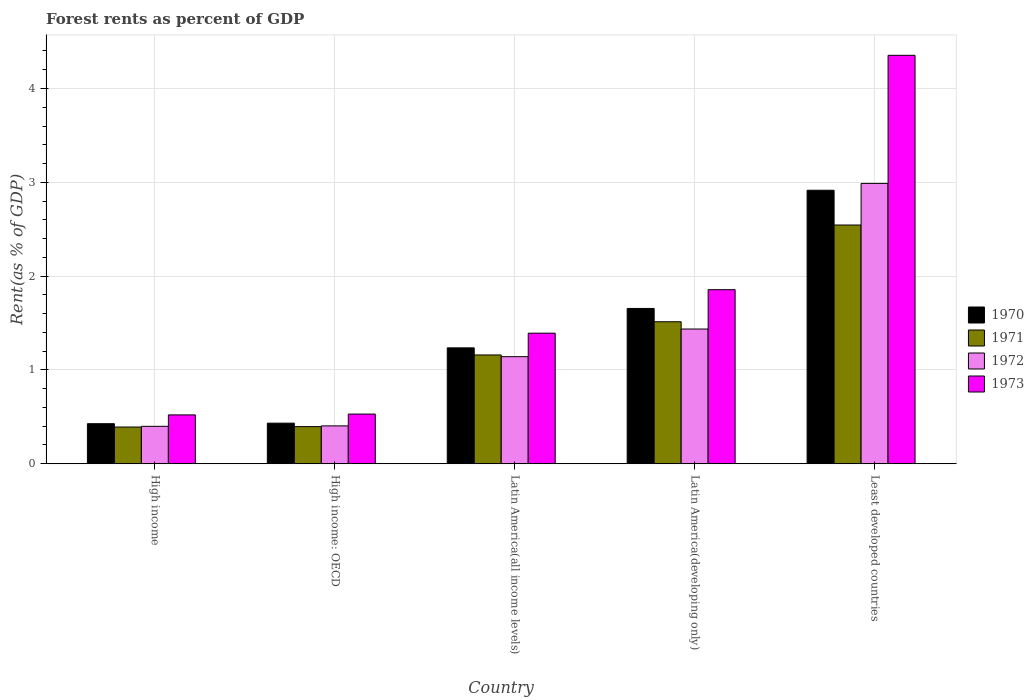How many different coloured bars are there?
Your answer should be compact. 4. Are the number of bars per tick equal to the number of legend labels?
Provide a succinct answer. Yes. Are the number of bars on each tick of the X-axis equal?
Make the answer very short. Yes. How many bars are there on the 1st tick from the left?
Offer a terse response. 4. How many bars are there on the 4th tick from the right?
Provide a short and direct response. 4. What is the label of the 5th group of bars from the left?
Your answer should be very brief. Least developed countries. What is the forest rent in 1972 in Latin America(developing only)?
Offer a terse response. 1.44. Across all countries, what is the maximum forest rent in 1973?
Offer a very short reply. 4.35. Across all countries, what is the minimum forest rent in 1972?
Keep it short and to the point. 0.4. In which country was the forest rent in 1971 maximum?
Your response must be concise. Least developed countries. In which country was the forest rent in 1970 minimum?
Offer a terse response. High income. What is the total forest rent in 1973 in the graph?
Give a very brief answer. 8.65. What is the difference between the forest rent in 1972 in High income: OECD and that in Latin America(developing only)?
Ensure brevity in your answer.  -1.03. What is the difference between the forest rent in 1971 in Least developed countries and the forest rent in 1970 in High income?
Offer a terse response. 2.12. What is the average forest rent in 1973 per country?
Provide a short and direct response. 1.73. What is the difference between the forest rent of/in 1970 and forest rent of/in 1971 in Least developed countries?
Your response must be concise. 0.37. What is the ratio of the forest rent in 1971 in Latin America(all income levels) to that in Least developed countries?
Keep it short and to the point. 0.46. Is the difference between the forest rent in 1970 in High income: OECD and Least developed countries greater than the difference between the forest rent in 1971 in High income: OECD and Least developed countries?
Offer a very short reply. No. What is the difference between the highest and the second highest forest rent in 1972?
Ensure brevity in your answer.  -1.55. What is the difference between the highest and the lowest forest rent in 1970?
Your response must be concise. 2.49. Is the sum of the forest rent in 1973 in High income and Latin America(developing only) greater than the maximum forest rent in 1970 across all countries?
Provide a short and direct response. No. Is it the case that in every country, the sum of the forest rent in 1972 and forest rent in 1971 is greater than the sum of forest rent in 1970 and forest rent in 1973?
Ensure brevity in your answer.  No. What does the 3rd bar from the left in Latin America(all income levels) represents?
Ensure brevity in your answer.  1972. Are all the bars in the graph horizontal?
Your response must be concise. No. Are the values on the major ticks of Y-axis written in scientific E-notation?
Your response must be concise. No. Does the graph contain any zero values?
Provide a short and direct response. No. Does the graph contain grids?
Your answer should be very brief. Yes. Where does the legend appear in the graph?
Your answer should be compact. Center right. What is the title of the graph?
Your answer should be compact. Forest rents as percent of GDP. What is the label or title of the X-axis?
Ensure brevity in your answer.  Country. What is the label or title of the Y-axis?
Offer a terse response. Rent(as % of GDP). What is the Rent(as % of GDP) in 1970 in High income?
Make the answer very short. 0.43. What is the Rent(as % of GDP) in 1971 in High income?
Keep it short and to the point. 0.39. What is the Rent(as % of GDP) of 1972 in High income?
Ensure brevity in your answer.  0.4. What is the Rent(as % of GDP) of 1973 in High income?
Give a very brief answer. 0.52. What is the Rent(as % of GDP) in 1970 in High income: OECD?
Give a very brief answer. 0.43. What is the Rent(as % of GDP) in 1971 in High income: OECD?
Keep it short and to the point. 0.4. What is the Rent(as % of GDP) of 1972 in High income: OECD?
Give a very brief answer. 0.4. What is the Rent(as % of GDP) in 1973 in High income: OECD?
Your answer should be compact. 0.53. What is the Rent(as % of GDP) of 1970 in Latin America(all income levels)?
Offer a terse response. 1.24. What is the Rent(as % of GDP) in 1971 in Latin America(all income levels)?
Your answer should be compact. 1.16. What is the Rent(as % of GDP) of 1972 in Latin America(all income levels)?
Keep it short and to the point. 1.14. What is the Rent(as % of GDP) in 1973 in Latin America(all income levels)?
Your answer should be compact. 1.39. What is the Rent(as % of GDP) in 1970 in Latin America(developing only)?
Provide a succinct answer. 1.66. What is the Rent(as % of GDP) of 1971 in Latin America(developing only)?
Provide a succinct answer. 1.51. What is the Rent(as % of GDP) of 1972 in Latin America(developing only)?
Your response must be concise. 1.44. What is the Rent(as % of GDP) in 1973 in Latin America(developing only)?
Make the answer very short. 1.86. What is the Rent(as % of GDP) in 1970 in Least developed countries?
Your answer should be very brief. 2.92. What is the Rent(as % of GDP) of 1971 in Least developed countries?
Your answer should be very brief. 2.54. What is the Rent(as % of GDP) in 1972 in Least developed countries?
Your answer should be very brief. 2.99. What is the Rent(as % of GDP) in 1973 in Least developed countries?
Your answer should be very brief. 4.35. Across all countries, what is the maximum Rent(as % of GDP) in 1970?
Your answer should be compact. 2.92. Across all countries, what is the maximum Rent(as % of GDP) of 1971?
Make the answer very short. 2.54. Across all countries, what is the maximum Rent(as % of GDP) in 1972?
Offer a terse response. 2.99. Across all countries, what is the maximum Rent(as % of GDP) in 1973?
Your answer should be compact. 4.35. Across all countries, what is the minimum Rent(as % of GDP) of 1970?
Provide a short and direct response. 0.43. Across all countries, what is the minimum Rent(as % of GDP) in 1971?
Offer a terse response. 0.39. Across all countries, what is the minimum Rent(as % of GDP) in 1972?
Give a very brief answer. 0.4. Across all countries, what is the minimum Rent(as % of GDP) of 1973?
Your response must be concise. 0.52. What is the total Rent(as % of GDP) in 1970 in the graph?
Provide a succinct answer. 6.67. What is the total Rent(as % of GDP) of 1971 in the graph?
Provide a succinct answer. 6. What is the total Rent(as % of GDP) in 1972 in the graph?
Make the answer very short. 6.37. What is the total Rent(as % of GDP) in 1973 in the graph?
Keep it short and to the point. 8.65. What is the difference between the Rent(as % of GDP) in 1970 in High income and that in High income: OECD?
Ensure brevity in your answer.  -0.01. What is the difference between the Rent(as % of GDP) of 1971 in High income and that in High income: OECD?
Your answer should be very brief. -0. What is the difference between the Rent(as % of GDP) in 1972 in High income and that in High income: OECD?
Provide a short and direct response. -0. What is the difference between the Rent(as % of GDP) in 1973 in High income and that in High income: OECD?
Keep it short and to the point. -0.01. What is the difference between the Rent(as % of GDP) in 1970 in High income and that in Latin America(all income levels)?
Provide a short and direct response. -0.81. What is the difference between the Rent(as % of GDP) of 1971 in High income and that in Latin America(all income levels)?
Give a very brief answer. -0.77. What is the difference between the Rent(as % of GDP) of 1972 in High income and that in Latin America(all income levels)?
Your answer should be compact. -0.74. What is the difference between the Rent(as % of GDP) in 1973 in High income and that in Latin America(all income levels)?
Give a very brief answer. -0.87. What is the difference between the Rent(as % of GDP) of 1970 in High income and that in Latin America(developing only)?
Provide a short and direct response. -1.23. What is the difference between the Rent(as % of GDP) in 1971 in High income and that in Latin America(developing only)?
Ensure brevity in your answer.  -1.12. What is the difference between the Rent(as % of GDP) in 1972 in High income and that in Latin America(developing only)?
Provide a succinct answer. -1.04. What is the difference between the Rent(as % of GDP) of 1973 in High income and that in Latin America(developing only)?
Your answer should be compact. -1.33. What is the difference between the Rent(as % of GDP) in 1970 in High income and that in Least developed countries?
Provide a short and direct response. -2.49. What is the difference between the Rent(as % of GDP) of 1971 in High income and that in Least developed countries?
Make the answer very short. -2.15. What is the difference between the Rent(as % of GDP) in 1972 in High income and that in Least developed countries?
Your answer should be compact. -2.59. What is the difference between the Rent(as % of GDP) of 1973 in High income and that in Least developed countries?
Provide a succinct answer. -3.83. What is the difference between the Rent(as % of GDP) in 1970 in High income: OECD and that in Latin America(all income levels)?
Provide a short and direct response. -0.8. What is the difference between the Rent(as % of GDP) of 1971 in High income: OECD and that in Latin America(all income levels)?
Your answer should be very brief. -0.76. What is the difference between the Rent(as % of GDP) in 1972 in High income: OECD and that in Latin America(all income levels)?
Provide a short and direct response. -0.74. What is the difference between the Rent(as % of GDP) of 1973 in High income: OECD and that in Latin America(all income levels)?
Offer a very short reply. -0.86. What is the difference between the Rent(as % of GDP) of 1970 in High income: OECD and that in Latin America(developing only)?
Give a very brief answer. -1.22. What is the difference between the Rent(as % of GDP) of 1971 in High income: OECD and that in Latin America(developing only)?
Keep it short and to the point. -1.12. What is the difference between the Rent(as % of GDP) of 1972 in High income: OECD and that in Latin America(developing only)?
Your response must be concise. -1.03. What is the difference between the Rent(as % of GDP) of 1973 in High income: OECD and that in Latin America(developing only)?
Offer a very short reply. -1.33. What is the difference between the Rent(as % of GDP) in 1970 in High income: OECD and that in Least developed countries?
Provide a succinct answer. -2.48. What is the difference between the Rent(as % of GDP) in 1971 in High income: OECD and that in Least developed countries?
Give a very brief answer. -2.15. What is the difference between the Rent(as % of GDP) in 1972 in High income: OECD and that in Least developed countries?
Your response must be concise. -2.58. What is the difference between the Rent(as % of GDP) in 1973 in High income: OECD and that in Least developed countries?
Your answer should be compact. -3.82. What is the difference between the Rent(as % of GDP) in 1970 in Latin America(all income levels) and that in Latin America(developing only)?
Provide a short and direct response. -0.42. What is the difference between the Rent(as % of GDP) in 1971 in Latin America(all income levels) and that in Latin America(developing only)?
Give a very brief answer. -0.35. What is the difference between the Rent(as % of GDP) of 1972 in Latin America(all income levels) and that in Latin America(developing only)?
Your response must be concise. -0.29. What is the difference between the Rent(as % of GDP) of 1973 in Latin America(all income levels) and that in Latin America(developing only)?
Your answer should be compact. -0.46. What is the difference between the Rent(as % of GDP) in 1970 in Latin America(all income levels) and that in Least developed countries?
Offer a terse response. -1.68. What is the difference between the Rent(as % of GDP) in 1971 in Latin America(all income levels) and that in Least developed countries?
Ensure brevity in your answer.  -1.39. What is the difference between the Rent(as % of GDP) of 1972 in Latin America(all income levels) and that in Least developed countries?
Provide a succinct answer. -1.85. What is the difference between the Rent(as % of GDP) of 1973 in Latin America(all income levels) and that in Least developed countries?
Your answer should be very brief. -2.96. What is the difference between the Rent(as % of GDP) in 1970 in Latin America(developing only) and that in Least developed countries?
Offer a very short reply. -1.26. What is the difference between the Rent(as % of GDP) of 1971 in Latin America(developing only) and that in Least developed countries?
Offer a terse response. -1.03. What is the difference between the Rent(as % of GDP) in 1972 in Latin America(developing only) and that in Least developed countries?
Provide a short and direct response. -1.55. What is the difference between the Rent(as % of GDP) of 1973 in Latin America(developing only) and that in Least developed countries?
Keep it short and to the point. -2.5. What is the difference between the Rent(as % of GDP) in 1970 in High income and the Rent(as % of GDP) in 1971 in High income: OECD?
Your answer should be very brief. 0.03. What is the difference between the Rent(as % of GDP) of 1970 in High income and the Rent(as % of GDP) of 1972 in High income: OECD?
Offer a terse response. 0.02. What is the difference between the Rent(as % of GDP) of 1970 in High income and the Rent(as % of GDP) of 1973 in High income: OECD?
Provide a short and direct response. -0.1. What is the difference between the Rent(as % of GDP) of 1971 in High income and the Rent(as % of GDP) of 1972 in High income: OECD?
Your answer should be compact. -0.01. What is the difference between the Rent(as % of GDP) in 1971 in High income and the Rent(as % of GDP) in 1973 in High income: OECD?
Keep it short and to the point. -0.14. What is the difference between the Rent(as % of GDP) of 1972 in High income and the Rent(as % of GDP) of 1973 in High income: OECD?
Offer a very short reply. -0.13. What is the difference between the Rent(as % of GDP) in 1970 in High income and the Rent(as % of GDP) in 1971 in Latin America(all income levels)?
Ensure brevity in your answer.  -0.73. What is the difference between the Rent(as % of GDP) in 1970 in High income and the Rent(as % of GDP) in 1972 in Latin America(all income levels)?
Ensure brevity in your answer.  -0.71. What is the difference between the Rent(as % of GDP) of 1970 in High income and the Rent(as % of GDP) of 1973 in Latin America(all income levels)?
Offer a terse response. -0.96. What is the difference between the Rent(as % of GDP) of 1971 in High income and the Rent(as % of GDP) of 1972 in Latin America(all income levels)?
Your answer should be very brief. -0.75. What is the difference between the Rent(as % of GDP) in 1971 in High income and the Rent(as % of GDP) in 1973 in Latin America(all income levels)?
Provide a succinct answer. -1. What is the difference between the Rent(as % of GDP) of 1972 in High income and the Rent(as % of GDP) of 1973 in Latin America(all income levels)?
Offer a terse response. -0.99. What is the difference between the Rent(as % of GDP) in 1970 in High income and the Rent(as % of GDP) in 1971 in Latin America(developing only)?
Offer a very short reply. -1.09. What is the difference between the Rent(as % of GDP) of 1970 in High income and the Rent(as % of GDP) of 1972 in Latin America(developing only)?
Make the answer very short. -1.01. What is the difference between the Rent(as % of GDP) of 1970 in High income and the Rent(as % of GDP) of 1973 in Latin America(developing only)?
Keep it short and to the point. -1.43. What is the difference between the Rent(as % of GDP) in 1971 in High income and the Rent(as % of GDP) in 1972 in Latin America(developing only)?
Offer a terse response. -1.04. What is the difference between the Rent(as % of GDP) in 1971 in High income and the Rent(as % of GDP) in 1973 in Latin America(developing only)?
Your answer should be compact. -1.46. What is the difference between the Rent(as % of GDP) of 1972 in High income and the Rent(as % of GDP) of 1973 in Latin America(developing only)?
Ensure brevity in your answer.  -1.46. What is the difference between the Rent(as % of GDP) in 1970 in High income and the Rent(as % of GDP) in 1971 in Least developed countries?
Offer a very short reply. -2.12. What is the difference between the Rent(as % of GDP) of 1970 in High income and the Rent(as % of GDP) of 1972 in Least developed countries?
Offer a terse response. -2.56. What is the difference between the Rent(as % of GDP) in 1970 in High income and the Rent(as % of GDP) in 1973 in Least developed countries?
Your answer should be very brief. -3.93. What is the difference between the Rent(as % of GDP) in 1971 in High income and the Rent(as % of GDP) in 1972 in Least developed countries?
Offer a terse response. -2.6. What is the difference between the Rent(as % of GDP) in 1971 in High income and the Rent(as % of GDP) in 1973 in Least developed countries?
Your answer should be compact. -3.96. What is the difference between the Rent(as % of GDP) in 1972 in High income and the Rent(as % of GDP) in 1973 in Least developed countries?
Keep it short and to the point. -3.95. What is the difference between the Rent(as % of GDP) in 1970 in High income: OECD and the Rent(as % of GDP) in 1971 in Latin America(all income levels)?
Provide a short and direct response. -0.73. What is the difference between the Rent(as % of GDP) in 1970 in High income: OECD and the Rent(as % of GDP) in 1972 in Latin America(all income levels)?
Provide a short and direct response. -0.71. What is the difference between the Rent(as % of GDP) of 1970 in High income: OECD and the Rent(as % of GDP) of 1973 in Latin America(all income levels)?
Your answer should be very brief. -0.96. What is the difference between the Rent(as % of GDP) in 1971 in High income: OECD and the Rent(as % of GDP) in 1972 in Latin America(all income levels)?
Provide a succinct answer. -0.75. What is the difference between the Rent(as % of GDP) in 1971 in High income: OECD and the Rent(as % of GDP) in 1973 in Latin America(all income levels)?
Provide a short and direct response. -1. What is the difference between the Rent(as % of GDP) of 1972 in High income: OECD and the Rent(as % of GDP) of 1973 in Latin America(all income levels)?
Keep it short and to the point. -0.99. What is the difference between the Rent(as % of GDP) of 1970 in High income: OECD and the Rent(as % of GDP) of 1971 in Latin America(developing only)?
Your answer should be compact. -1.08. What is the difference between the Rent(as % of GDP) of 1970 in High income: OECD and the Rent(as % of GDP) of 1972 in Latin America(developing only)?
Your response must be concise. -1. What is the difference between the Rent(as % of GDP) in 1970 in High income: OECD and the Rent(as % of GDP) in 1973 in Latin America(developing only)?
Your answer should be compact. -1.42. What is the difference between the Rent(as % of GDP) in 1971 in High income: OECD and the Rent(as % of GDP) in 1972 in Latin America(developing only)?
Provide a short and direct response. -1.04. What is the difference between the Rent(as % of GDP) in 1971 in High income: OECD and the Rent(as % of GDP) in 1973 in Latin America(developing only)?
Your answer should be very brief. -1.46. What is the difference between the Rent(as % of GDP) of 1972 in High income: OECD and the Rent(as % of GDP) of 1973 in Latin America(developing only)?
Give a very brief answer. -1.45. What is the difference between the Rent(as % of GDP) in 1970 in High income: OECD and the Rent(as % of GDP) in 1971 in Least developed countries?
Keep it short and to the point. -2.11. What is the difference between the Rent(as % of GDP) of 1970 in High income: OECD and the Rent(as % of GDP) of 1972 in Least developed countries?
Give a very brief answer. -2.56. What is the difference between the Rent(as % of GDP) in 1970 in High income: OECD and the Rent(as % of GDP) in 1973 in Least developed countries?
Your response must be concise. -3.92. What is the difference between the Rent(as % of GDP) in 1971 in High income: OECD and the Rent(as % of GDP) in 1972 in Least developed countries?
Offer a very short reply. -2.59. What is the difference between the Rent(as % of GDP) of 1971 in High income: OECD and the Rent(as % of GDP) of 1973 in Least developed countries?
Provide a succinct answer. -3.96. What is the difference between the Rent(as % of GDP) of 1972 in High income: OECD and the Rent(as % of GDP) of 1973 in Least developed countries?
Keep it short and to the point. -3.95. What is the difference between the Rent(as % of GDP) of 1970 in Latin America(all income levels) and the Rent(as % of GDP) of 1971 in Latin America(developing only)?
Keep it short and to the point. -0.28. What is the difference between the Rent(as % of GDP) of 1970 in Latin America(all income levels) and the Rent(as % of GDP) of 1972 in Latin America(developing only)?
Your answer should be very brief. -0.2. What is the difference between the Rent(as % of GDP) in 1970 in Latin America(all income levels) and the Rent(as % of GDP) in 1973 in Latin America(developing only)?
Your answer should be compact. -0.62. What is the difference between the Rent(as % of GDP) in 1971 in Latin America(all income levels) and the Rent(as % of GDP) in 1972 in Latin America(developing only)?
Make the answer very short. -0.28. What is the difference between the Rent(as % of GDP) of 1971 in Latin America(all income levels) and the Rent(as % of GDP) of 1973 in Latin America(developing only)?
Your answer should be very brief. -0.7. What is the difference between the Rent(as % of GDP) in 1972 in Latin America(all income levels) and the Rent(as % of GDP) in 1973 in Latin America(developing only)?
Your answer should be compact. -0.71. What is the difference between the Rent(as % of GDP) in 1970 in Latin America(all income levels) and the Rent(as % of GDP) in 1971 in Least developed countries?
Provide a short and direct response. -1.31. What is the difference between the Rent(as % of GDP) in 1970 in Latin America(all income levels) and the Rent(as % of GDP) in 1972 in Least developed countries?
Your answer should be very brief. -1.75. What is the difference between the Rent(as % of GDP) in 1970 in Latin America(all income levels) and the Rent(as % of GDP) in 1973 in Least developed countries?
Your answer should be compact. -3.12. What is the difference between the Rent(as % of GDP) in 1971 in Latin America(all income levels) and the Rent(as % of GDP) in 1972 in Least developed countries?
Ensure brevity in your answer.  -1.83. What is the difference between the Rent(as % of GDP) of 1971 in Latin America(all income levels) and the Rent(as % of GDP) of 1973 in Least developed countries?
Keep it short and to the point. -3.19. What is the difference between the Rent(as % of GDP) of 1972 in Latin America(all income levels) and the Rent(as % of GDP) of 1973 in Least developed countries?
Provide a succinct answer. -3.21. What is the difference between the Rent(as % of GDP) in 1970 in Latin America(developing only) and the Rent(as % of GDP) in 1971 in Least developed countries?
Offer a terse response. -0.89. What is the difference between the Rent(as % of GDP) of 1970 in Latin America(developing only) and the Rent(as % of GDP) of 1972 in Least developed countries?
Provide a short and direct response. -1.33. What is the difference between the Rent(as % of GDP) in 1970 in Latin America(developing only) and the Rent(as % of GDP) in 1973 in Least developed countries?
Give a very brief answer. -2.7. What is the difference between the Rent(as % of GDP) of 1971 in Latin America(developing only) and the Rent(as % of GDP) of 1972 in Least developed countries?
Offer a very short reply. -1.47. What is the difference between the Rent(as % of GDP) of 1971 in Latin America(developing only) and the Rent(as % of GDP) of 1973 in Least developed countries?
Provide a short and direct response. -2.84. What is the difference between the Rent(as % of GDP) in 1972 in Latin America(developing only) and the Rent(as % of GDP) in 1973 in Least developed countries?
Keep it short and to the point. -2.92. What is the average Rent(as % of GDP) in 1970 per country?
Your answer should be compact. 1.33. What is the average Rent(as % of GDP) of 1971 per country?
Keep it short and to the point. 1.2. What is the average Rent(as % of GDP) of 1972 per country?
Ensure brevity in your answer.  1.27. What is the average Rent(as % of GDP) in 1973 per country?
Offer a very short reply. 1.73. What is the difference between the Rent(as % of GDP) in 1970 and Rent(as % of GDP) in 1971 in High income?
Ensure brevity in your answer.  0.04. What is the difference between the Rent(as % of GDP) in 1970 and Rent(as % of GDP) in 1972 in High income?
Your answer should be compact. 0.03. What is the difference between the Rent(as % of GDP) in 1970 and Rent(as % of GDP) in 1973 in High income?
Offer a terse response. -0.09. What is the difference between the Rent(as % of GDP) of 1971 and Rent(as % of GDP) of 1972 in High income?
Offer a terse response. -0.01. What is the difference between the Rent(as % of GDP) in 1971 and Rent(as % of GDP) in 1973 in High income?
Provide a succinct answer. -0.13. What is the difference between the Rent(as % of GDP) in 1972 and Rent(as % of GDP) in 1973 in High income?
Offer a very short reply. -0.12. What is the difference between the Rent(as % of GDP) in 1970 and Rent(as % of GDP) in 1971 in High income: OECD?
Offer a very short reply. 0.04. What is the difference between the Rent(as % of GDP) of 1970 and Rent(as % of GDP) of 1972 in High income: OECD?
Give a very brief answer. 0.03. What is the difference between the Rent(as % of GDP) in 1970 and Rent(as % of GDP) in 1973 in High income: OECD?
Keep it short and to the point. -0.1. What is the difference between the Rent(as % of GDP) of 1971 and Rent(as % of GDP) of 1972 in High income: OECD?
Keep it short and to the point. -0.01. What is the difference between the Rent(as % of GDP) in 1971 and Rent(as % of GDP) in 1973 in High income: OECD?
Your answer should be very brief. -0.13. What is the difference between the Rent(as % of GDP) of 1972 and Rent(as % of GDP) of 1973 in High income: OECD?
Make the answer very short. -0.13. What is the difference between the Rent(as % of GDP) of 1970 and Rent(as % of GDP) of 1971 in Latin America(all income levels)?
Provide a succinct answer. 0.08. What is the difference between the Rent(as % of GDP) in 1970 and Rent(as % of GDP) in 1972 in Latin America(all income levels)?
Your response must be concise. 0.09. What is the difference between the Rent(as % of GDP) in 1970 and Rent(as % of GDP) in 1973 in Latin America(all income levels)?
Provide a succinct answer. -0.16. What is the difference between the Rent(as % of GDP) of 1971 and Rent(as % of GDP) of 1972 in Latin America(all income levels)?
Offer a terse response. 0.02. What is the difference between the Rent(as % of GDP) of 1971 and Rent(as % of GDP) of 1973 in Latin America(all income levels)?
Your answer should be compact. -0.23. What is the difference between the Rent(as % of GDP) of 1972 and Rent(as % of GDP) of 1973 in Latin America(all income levels)?
Provide a succinct answer. -0.25. What is the difference between the Rent(as % of GDP) in 1970 and Rent(as % of GDP) in 1971 in Latin America(developing only)?
Your answer should be compact. 0.14. What is the difference between the Rent(as % of GDP) of 1970 and Rent(as % of GDP) of 1972 in Latin America(developing only)?
Give a very brief answer. 0.22. What is the difference between the Rent(as % of GDP) of 1970 and Rent(as % of GDP) of 1973 in Latin America(developing only)?
Ensure brevity in your answer.  -0.2. What is the difference between the Rent(as % of GDP) of 1971 and Rent(as % of GDP) of 1972 in Latin America(developing only)?
Offer a terse response. 0.08. What is the difference between the Rent(as % of GDP) in 1971 and Rent(as % of GDP) in 1973 in Latin America(developing only)?
Make the answer very short. -0.34. What is the difference between the Rent(as % of GDP) of 1972 and Rent(as % of GDP) of 1973 in Latin America(developing only)?
Keep it short and to the point. -0.42. What is the difference between the Rent(as % of GDP) in 1970 and Rent(as % of GDP) in 1971 in Least developed countries?
Offer a terse response. 0.37. What is the difference between the Rent(as % of GDP) of 1970 and Rent(as % of GDP) of 1972 in Least developed countries?
Offer a terse response. -0.07. What is the difference between the Rent(as % of GDP) of 1970 and Rent(as % of GDP) of 1973 in Least developed countries?
Make the answer very short. -1.44. What is the difference between the Rent(as % of GDP) in 1971 and Rent(as % of GDP) in 1972 in Least developed countries?
Your answer should be compact. -0.44. What is the difference between the Rent(as % of GDP) of 1971 and Rent(as % of GDP) of 1973 in Least developed countries?
Offer a terse response. -1.81. What is the difference between the Rent(as % of GDP) of 1972 and Rent(as % of GDP) of 1973 in Least developed countries?
Provide a short and direct response. -1.37. What is the ratio of the Rent(as % of GDP) of 1970 in High income to that in High income: OECD?
Keep it short and to the point. 0.99. What is the ratio of the Rent(as % of GDP) in 1973 in High income to that in High income: OECD?
Offer a very short reply. 0.98. What is the ratio of the Rent(as % of GDP) of 1970 in High income to that in Latin America(all income levels)?
Your response must be concise. 0.35. What is the ratio of the Rent(as % of GDP) in 1971 in High income to that in Latin America(all income levels)?
Ensure brevity in your answer.  0.34. What is the ratio of the Rent(as % of GDP) in 1972 in High income to that in Latin America(all income levels)?
Your response must be concise. 0.35. What is the ratio of the Rent(as % of GDP) of 1973 in High income to that in Latin America(all income levels)?
Provide a short and direct response. 0.37. What is the ratio of the Rent(as % of GDP) in 1970 in High income to that in Latin America(developing only)?
Keep it short and to the point. 0.26. What is the ratio of the Rent(as % of GDP) of 1971 in High income to that in Latin America(developing only)?
Make the answer very short. 0.26. What is the ratio of the Rent(as % of GDP) in 1972 in High income to that in Latin America(developing only)?
Ensure brevity in your answer.  0.28. What is the ratio of the Rent(as % of GDP) of 1973 in High income to that in Latin America(developing only)?
Make the answer very short. 0.28. What is the ratio of the Rent(as % of GDP) of 1970 in High income to that in Least developed countries?
Your answer should be compact. 0.15. What is the ratio of the Rent(as % of GDP) in 1971 in High income to that in Least developed countries?
Your answer should be very brief. 0.15. What is the ratio of the Rent(as % of GDP) in 1972 in High income to that in Least developed countries?
Offer a terse response. 0.13. What is the ratio of the Rent(as % of GDP) of 1973 in High income to that in Least developed countries?
Provide a short and direct response. 0.12. What is the ratio of the Rent(as % of GDP) of 1970 in High income: OECD to that in Latin America(all income levels)?
Offer a terse response. 0.35. What is the ratio of the Rent(as % of GDP) in 1971 in High income: OECD to that in Latin America(all income levels)?
Ensure brevity in your answer.  0.34. What is the ratio of the Rent(as % of GDP) of 1972 in High income: OECD to that in Latin America(all income levels)?
Your answer should be compact. 0.35. What is the ratio of the Rent(as % of GDP) in 1973 in High income: OECD to that in Latin America(all income levels)?
Offer a very short reply. 0.38. What is the ratio of the Rent(as % of GDP) in 1970 in High income: OECD to that in Latin America(developing only)?
Your answer should be very brief. 0.26. What is the ratio of the Rent(as % of GDP) in 1971 in High income: OECD to that in Latin America(developing only)?
Keep it short and to the point. 0.26. What is the ratio of the Rent(as % of GDP) in 1972 in High income: OECD to that in Latin America(developing only)?
Ensure brevity in your answer.  0.28. What is the ratio of the Rent(as % of GDP) in 1973 in High income: OECD to that in Latin America(developing only)?
Your answer should be compact. 0.29. What is the ratio of the Rent(as % of GDP) of 1970 in High income: OECD to that in Least developed countries?
Your answer should be very brief. 0.15. What is the ratio of the Rent(as % of GDP) of 1971 in High income: OECD to that in Least developed countries?
Your answer should be compact. 0.16. What is the ratio of the Rent(as % of GDP) of 1972 in High income: OECD to that in Least developed countries?
Your response must be concise. 0.14. What is the ratio of the Rent(as % of GDP) in 1973 in High income: OECD to that in Least developed countries?
Provide a short and direct response. 0.12. What is the ratio of the Rent(as % of GDP) in 1970 in Latin America(all income levels) to that in Latin America(developing only)?
Your response must be concise. 0.75. What is the ratio of the Rent(as % of GDP) in 1971 in Latin America(all income levels) to that in Latin America(developing only)?
Your answer should be very brief. 0.77. What is the ratio of the Rent(as % of GDP) in 1972 in Latin America(all income levels) to that in Latin America(developing only)?
Your answer should be compact. 0.79. What is the ratio of the Rent(as % of GDP) in 1973 in Latin America(all income levels) to that in Latin America(developing only)?
Offer a very short reply. 0.75. What is the ratio of the Rent(as % of GDP) of 1970 in Latin America(all income levels) to that in Least developed countries?
Make the answer very short. 0.42. What is the ratio of the Rent(as % of GDP) in 1971 in Latin America(all income levels) to that in Least developed countries?
Give a very brief answer. 0.46. What is the ratio of the Rent(as % of GDP) in 1972 in Latin America(all income levels) to that in Least developed countries?
Provide a short and direct response. 0.38. What is the ratio of the Rent(as % of GDP) of 1973 in Latin America(all income levels) to that in Least developed countries?
Provide a succinct answer. 0.32. What is the ratio of the Rent(as % of GDP) of 1970 in Latin America(developing only) to that in Least developed countries?
Your answer should be very brief. 0.57. What is the ratio of the Rent(as % of GDP) of 1971 in Latin America(developing only) to that in Least developed countries?
Provide a short and direct response. 0.59. What is the ratio of the Rent(as % of GDP) in 1972 in Latin America(developing only) to that in Least developed countries?
Your response must be concise. 0.48. What is the ratio of the Rent(as % of GDP) of 1973 in Latin America(developing only) to that in Least developed countries?
Your answer should be very brief. 0.43. What is the difference between the highest and the second highest Rent(as % of GDP) of 1970?
Your answer should be compact. 1.26. What is the difference between the highest and the second highest Rent(as % of GDP) of 1971?
Give a very brief answer. 1.03. What is the difference between the highest and the second highest Rent(as % of GDP) of 1972?
Offer a very short reply. 1.55. What is the difference between the highest and the second highest Rent(as % of GDP) of 1973?
Offer a terse response. 2.5. What is the difference between the highest and the lowest Rent(as % of GDP) in 1970?
Your response must be concise. 2.49. What is the difference between the highest and the lowest Rent(as % of GDP) of 1971?
Make the answer very short. 2.15. What is the difference between the highest and the lowest Rent(as % of GDP) in 1972?
Make the answer very short. 2.59. What is the difference between the highest and the lowest Rent(as % of GDP) in 1973?
Give a very brief answer. 3.83. 